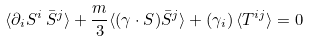<formula> <loc_0><loc_0><loc_500><loc_500>\langle \partial _ { i } S ^ { i } \, \bar { S } ^ { j } \rangle + \frac { m } { 3 } \langle ( \gamma \cdot S ) \bar { S } ^ { j } \rangle + ( \gamma _ { i } ) \, \langle T ^ { i j } \rangle = 0</formula> 